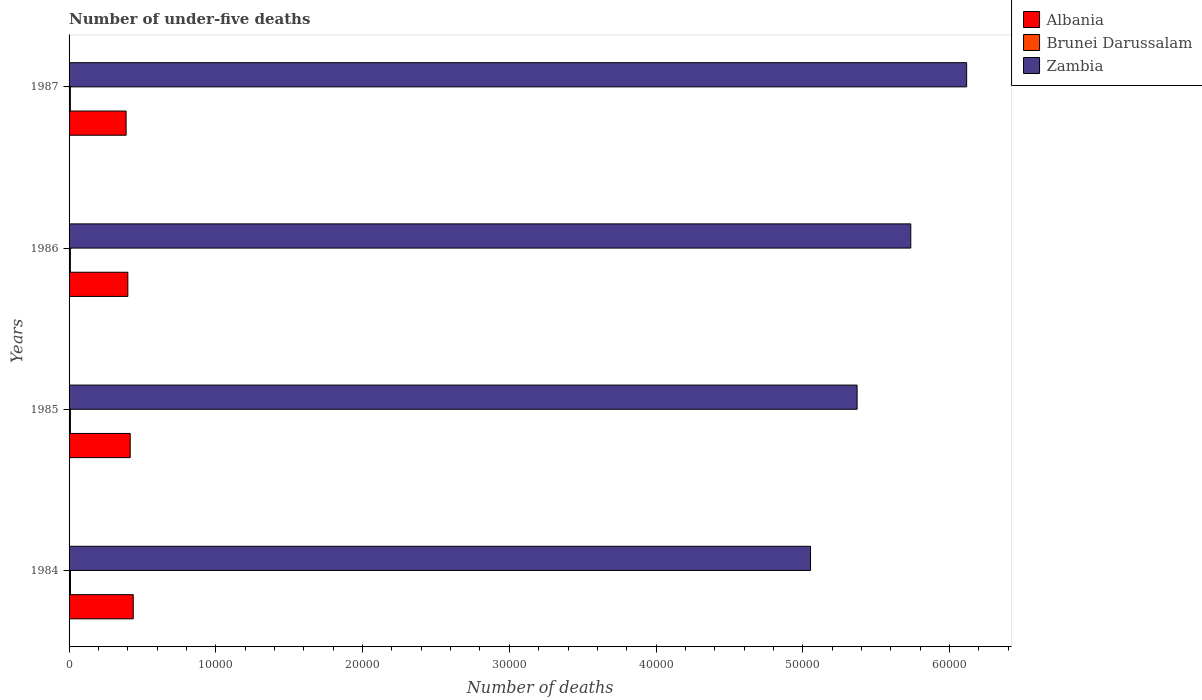How many different coloured bars are there?
Your answer should be compact. 3. How many groups of bars are there?
Your answer should be compact. 4. How many bars are there on the 3rd tick from the top?
Give a very brief answer. 3. How many bars are there on the 1st tick from the bottom?
Give a very brief answer. 3. In how many cases, is the number of bars for a given year not equal to the number of legend labels?
Provide a succinct answer. 0. What is the number of under-five deaths in Albania in 1987?
Keep it short and to the point. 3887. Across all years, what is the maximum number of under-five deaths in Albania?
Keep it short and to the point. 4373. Across all years, what is the minimum number of under-five deaths in Albania?
Your answer should be very brief. 3887. What is the total number of under-five deaths in Zambia in the graph?
Provide a short and direct response. 2.23e+05. What is the difference between the number of under-five deaths in Zambia in 1986 and that in 1987?
Your answer should be very brief. -3808. What is the difference between the number of under-five deaths in Brunei Darussalam in 1987 and the number of under-five deaths in Zambia in 1986?
Your response must be concise. -5.73e+04. What is the average number of under-five deaths in Zambia per year?
Your answer should be compact. 5.57e+04. In the year 1986, what is the difference between the number of under-five deaths in Albania and number of under-five deaths in Brunei Darussalam?
Give a very brief answer. 3916. In how many years, is the number of under-five deaths in Brunei Darussalam greater than 36000 ?
Provide a succinct answer. 0. What is the ratio of the number of under-five deaths in Brunei Darussalam in 1984 to that in 1986?
Give a very brief answer. 1.07. Is the sum of the number of under-five deaths in Albania in 1985 and 1986 greater than the maximum number of under-five deaths in Zambia across all years?
Your answer should be compact. No. What does the 2nd bar from the top in 1987 represents?
Your answer should be very brief. Brunei Darussalam. What does the 1st bar from the bottom in 1985 represents?
Offer a terse response. Albania. Is it the case that in every year, the sum of the number of under-five deaths in Zambia and number of under-five deaths in Albania is greater than the number of under-five deaths in Brunei Darussalam?
Offer a very short reply. Yes. How many bars are there?
Keep it short and to the point. 12. How many years are there in the graph?
Provide a short and direct response. 4. Does the graph contain grids?
Your answer should be compact. No. Where does the legend appear in the graph?
Your answer should be compact. Top right. How are the legend labels stacked?
Offer a very short reply. Vertical. What is the title of the graph?
Your answer should be very brief. Number of under-five deaths. What is the label or title of the X-axis?
Provide a short and direct response. Number of deaths. What is the Number of deaths of Albania in 1984?
Ensure brevity in your answer.  4373. What is the Number of deaths in Brunei Darussalam in 1984?
Give a very brief answer. 95. What is the Number of deaths in Zambia in 1984?
Provide a short and direct response. 5.05e+04. What is the Number of deaths in Albania in 1985?
Provide a short and direct response. 4166. What is the Number of deaths of Brunei Darussalam in 1985?
Your answer should be compact. 92. What is the Number of deaths of Zambia in 1985?
Keep it short and to the point. 5.37e+04. What is the Number of deaths of Albania in 1986?
Offer a terse response. 4005. What is the Number of deaths in Brunei Darussalam in 1986?
Offer a very short reply. 89. What is the Number of deaths of Zambia in 1986?
Offer a very short reply. 5.74e+04. What is the Number of deaths of Albania in 1987?
Offer a very short reply. 3887. What is the Number of deaths of Zambia in 1987?
Your answer should be compact. 6.12e+04. Across all years, what is the maximum Number of deaths of Albania?
Keep it short and to the point. 4373. Across all years, what is the maximum Number of deaths of Brunei Darussalam?
Offer a very short reply. 95. Across all years, what is the maximum Number of deaths of Zambia?
Give a very brief answer. 6.12e+04. Across all years, what is the minimum Number of deaths of Albania?
Your answer should be very brief. 3887. Across all years, what is the minimum Number of deaths in Brunei Darussalam?
Give a very brief answer. 88. Across all years, what is the minimum Number of deaths of Zambia?
Your answer should be very brief. 5.05e+04. What is the total Number of deaths of Albania in the graph?
Provide a short and direct response. 1.64e+04. What is the total Number of deaths of Brunei Darussalam in the graph?
Make the answer very short. 364. What is the total Number of deaths of Zambia in the graph?
Your response must be concise. 2.23e+05. What is the difference between the Number of deaths of Albania in 1984 and that in 1985?
Your response must be concise. 207. What is the difference between the Number of deaths of Brunei Darussalam in 1984 and that in 1985?
Provide a succinct answer. 3. What is the difference between the Number of deaths in Zambia in 1984 and that in 1985?
Your answer should be very brief. -3173. What is the difference between the Number of deaths in Albania in 1984 and that in 1986?
Make the answer very short. 368. What is the difference between the Number of deaths of Brunei Darussalam in 1984 and that in 1986?
Your answer should be very brief. 6. What is the difference between the Number of deaths in Zambia in 1984 and that in 1986?
Keep it short and to the point. -6831. What is the difference between the Number of deaths of Albania in 1984 and that in 1987?
Make the answer very short. 486. What is the difference between the Number of deaths in Brunei Darussalam in 1984 and that in 1987?
Keep it short and to the point. 7. What is the difference between the Number of deaths of Zambia in 1984 and that in 1987?
Offer a very short reply. -1.06e+04. What is the difference between the Number of deaths of Albania in 1985 and that in 1986?
Ensure brevity in your answer.  161. What is the difference between the Number of deaths of Zambia in 1985 and that in 1986?
Give a very brief answer. -3658. What is the difference between the Number of deaths of Albania in 1985 and that in 1987?
Your response must be concise. 279. What is the difference between the Number of deaths in Zambia in 1985 and that in 1987?
Keep it short and to the point. -7466. What is the difference between the Number of deaths of Albania in 1986 and that in 1987?
Offer a very short reply. 118. What is the difference between the Number of deaths of Brunei Darussalam in 1986 and that in 1987?
Ensure brevity in your answer.  1. What is the difference between the Number of deaths of Zambia in 1986 and that in 1987?
Your response must be concise. -3808. What is the difference between the Number of deaths of Albania in 1984 and the Number of deaths of Brunei Darussalam in 1985?
Offer a very short reply. 4281. What is the difference between the Number of deaths in Albania in 1984 and the Number of deaths in Zambia in 1985?
Your answer should be very brief. -4.93e+04. What is the difference between the Number of deaths in Brunei Darussalam in 1984 and the Number of deaths in Zambia in 1985?
Ensure brevity in your answer.  -5.36e+04. What is the difference between the Number of deaths of Albania in 1984 and the Number of deaths of Brunei Darussalam in 1986?
Make the answer very short. 4284. What is the difference between the Number of deaths in Albania in 1984 and the Number of deaths in Zambia in 1986?
Offer a terse response. -5.30e+04. What is the difference between the Number of deaths of Brunei Darussalam in 1984 and the Number of deaths of Zambia in 1986?
Your response must be concise. -5.73e+04. What is the difference between the Number of deaths of Albania in 1984 and the Number of deaths of Brunei Darussalam in 1987?
Give a very brief answer. 4285. What is the difference between the Number of deaths of Albania in 1984 and the Number of deaths of Zambia in 1987?
Make the answer very short. -5.68e+04. What is the difference between the Number of deaths in Brunei Darussalam in 1984 and the Number of deaths in Zambia in 1987?
Provide a succinct answer. -6.11e+04. What is the difference between the Number of deaths in Albania in 1985 and the Number of deaths in Brunei Darussalam in 1986?
Provide a short and direct response. 4077. What is the difference between the Number of deaths of Albania in 1985 and the Number of deaths of Zambia in 1986?
Offer a very short reply. -5.32e+04. What is the difference between the Number of deaths in Brunei Darussalam in 1985 and the Number of deaths in Zambia in 1986?
Your response must be concise. -5.73e+04. What is the difference between the Number of deaths of Albania in 1985 and the Number of deaths of Brunei Darussalam in 1987?
Make the answer very short. 4078. What is the difference between the Number of deaths of Albania in 1985 and the Number of deaths of Zambia in 1987?
Your response must be concise. -5.70e+04. What is the difference between the Number of deaths in Brunei Darussalam in 1985 and the Number of deaths in Zambia in 1987?
Keep it short and to the point. -6.11e+04. What is the difference between the Number of deaths of Albania in 1986 and the Number of deaths of Brunei Darussalam in 1987?
Offer a terse response. 3917. What is the difference between the Number of deaths in Albania in 1986 and the Number of deaths in Zambia in 1987?
Your answer should be very brief. -5.72e+04. What is the difference between the Number of deaths in Brunei Darussalam in 1986 and the Number of deaths in Zambia in 1987?
Provide a short and direct response. -6.11e+04. What is the average Number of deaths of Albania per year?
Make the answer very short. 4107.75. What is the average Number of deaths in Brunei Darussalam per year?
Make the answer very short. 91. What is the average Number of deaths in Zambia per year?
Keep it short and to the point. 5.57e+04. In the year 1984, what is the difference between the Number of deaths in Albania and Number of deaths in Brunei Darussalam?
Keep it short and to the point. 4278. In the year 1984, what is the difference between the Number of deaths of Albania and Number of deaths of Zambia?
Provide a short and direct response. -4.62e+04. In the year 1984, what is the difference between the Number of deaths of Brunei Darussalam and Number of deaths of Zambia?
Make the answer very short. -5.04e+04. In the year 1985, what is the difference between the Number of deaths of Albania and Number of deaths of Brunei Darussalam?
Your response must be concise. 4074. In the year 1985, what is the difference between the Number of deaths in Albania and Number of deaths in Zambia?
Offer a very short reply. -4.95e+04. In the year 1985, what is the difference between the Number of deaths in Brunei Darussalam and Number of deaths in Zambia?
Offer a very short reply. -5.36e+04. In the year 1986, what is the difference between the Number of deaths of Albania and Number of deaths of Brunei Darussalam?
Your answer should be compact. 3916. In the year 1986, what is the difference between the Number of deaths in Albania and Number of deaths in Zambia?
Ensure brevity in your answer.  -5.34e+04. In the year 1986, what is the difference between the Number of deaths of Brunei Darussalam and Number of deaths of Zambia?
Your response must be concise. -5.73e+04. In the year 1987, what is the difference between the Number of deaths of Albania and Number of deaths of Brunei Darussalam?
Ensure brevity in your answer.  3799. In the year 1987, what is the difference between the Number of deaths in Albania and Number of deaths in Zambia?
Your answer should be very brief. -5.73e+04. In the year 1987, what is the difference between the Number of deaths in Brunei Darussalam and Number of deaths in Zambia?
Keep it short and to the point. -6.11e+04. What is the ratio of the Number of deaths of Albania in 1984 to that in 1985?
Your answer should be compact. 1.05. What is the ratio of the Number of deaths of Brunei Darussalam in 1984 to that in 1985?
Make the answer very short. 1.03. What is the ratio of the Number of deaths of Zambia in 1984 to that in 1985?
Make the answer very short. 0.94. What is the ratio of the Number of deaths in Albania in 1984 to that in 1986?
Your response must be concise. 1.09. What is the ratio of the Number of deaths in Brunei Darussalam in 1984 to that in 1986?
Give a very brief answer. 1.07. What is the ratio of the Number of deaths of Zambia in 1984 to that in 1986?
Offer a very short reply. 0.88. What is the ratio of the Number of deaths of Brunei Darussalam in 1984 to that in 1987?
Provide a succinct answer. 1.08. What is the ratio of the Number of deaths of Zambia in 1984 to that in 1987?
Provide a short and direct response. 0.83. What is the ratio of the Number of deaths of Albania in 1985 to that in 1986?
Provide a succinct answer. 1.04. What is the ratio of the Number of deaths in Brunei Darussalam in 1985 to that in 1986?
Provide a short and direct response. 1.03. What is the ratio of the Number of deaths of Zambia in 1985 to that in 1986?
Make the answer very short. 0.94. What is the ratio of the Number of deaths in Albania in 1985 to that in 1987?
Keep it short and to the point. 1.07. What is the ratio of the Number of deaths in Brunei Darussalam in 1985 to that in 1987?
Offer a very short reply. 1.05. What is the ratio of the Number of deaths in Zambia in 1985 to that in 1987?
Your answer should be very brief. 0.88. What is the ratio of the Number of deaths in Albania in 1986 to that in 1987?
Your answer should be very brief. 1.03. What is the ratio of the Number of deaths of Brunei Darussalam in 1986 to that in 1987?
Keep it short and to the point. 1.01. What is the ratio of the Number of deaths in Zambia in 1986 to that in 1987?
Provide a short and direct response. 0.94. What is the difference between the highest and the second highest Number of deaths of Albania?
Offer a terse response. 207. What is the difference between the highest and the second highest Number of deaths of Brunei Darussalam?
Your response must be concise. 3. What is the difference between the highest and the second highest Number of deaths in Zambia?
Offer a very short reply. 3808. What is the difference between the highest and the lowest Number of deaths in Albania?
Keep it short and to the point. 486. What is the difference between the highest and the lowest Number of deaths of Brunei Darussalam?
Provide a succinct answer. 7. What is the difference between the highest and the lowest Number of deaths of Zambia?
Offer a very short reply. 1.06e+04. 